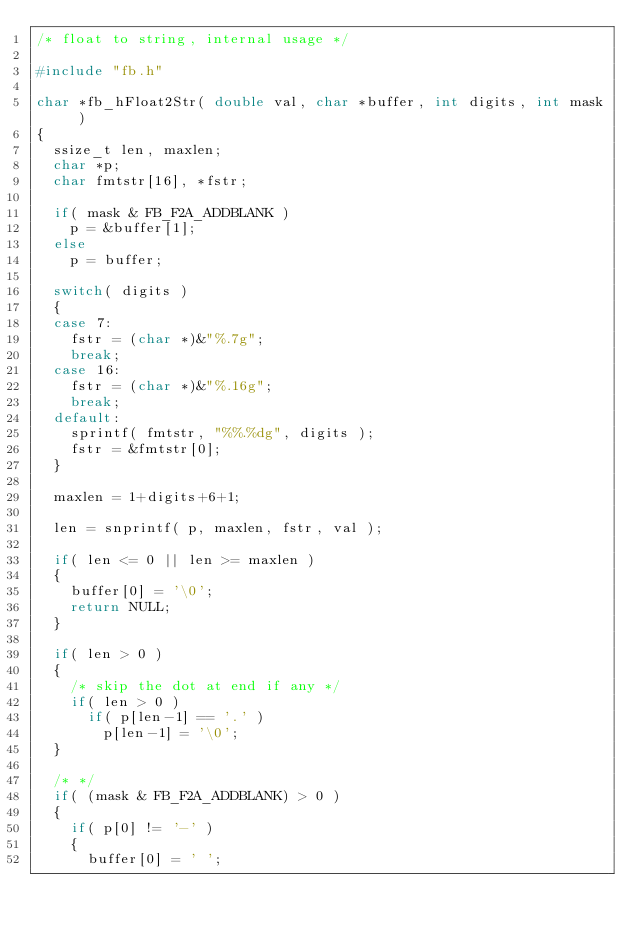<code> <loc_0><loc_0><loc_500><loc_500><_C_>/* float to string, internal usage */

#include "fb.h"

char *fb_hFloat2Str( double val, char *buffer, int digits, int mask )
{
	ssize_t len, maxlen;
	char *p;
	char fmtstr[16], *fstr;

	if( mask & FB_F2A_ADDBLANK )
		p = &buffer[1];
	else
		p = buffer;

	switch( digits )
	{
	case 7:
		fstr = (char *)&"%.7g";
		break;
	case 16:
		fstr = (char *)&"%.16g";
		break;
	default:
		sprintf( fmtstr, "%%.%dg", digits );
		fstr = &fmtstr[0];
	}

	maxlen = 1+digits+6+1;

	len = snprintf( p, maxlen, fstr, val );

	if( len <= 0 || len >= maxlen )
	{
		buffer[0] = '\0';
		return NULL;
	}

	if( len > 0 )
	{
		/* skip the dot at end if any */
		if( len > 0 )
			if( p[len-1] == '.' )
				p[len-1] = '\0';
	}

	/* */
	if( (mask & FB_F2A_ADDBLANK) > 0 )
	{
		if( p[0] != '-' )
		{
			buffer[0] = ' ';</code> 